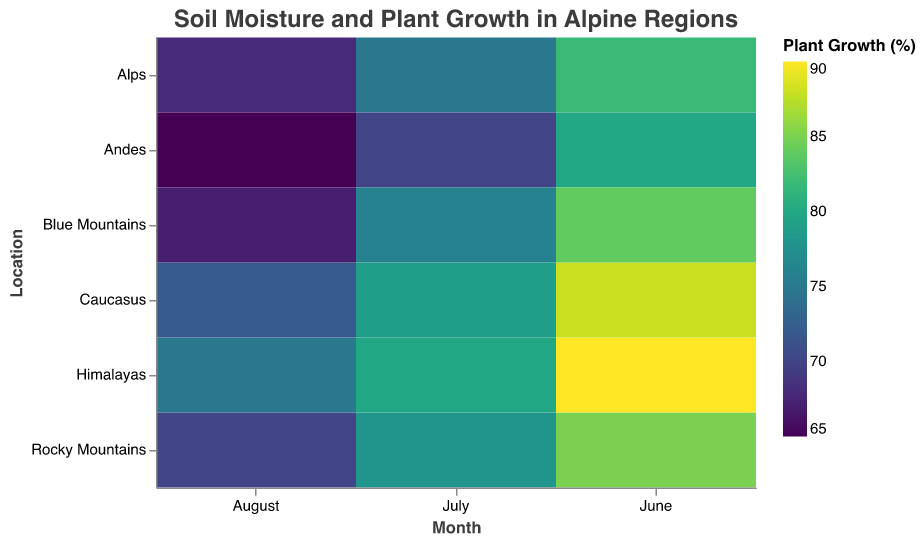What is the soil moisture percentage in the Himalayas in August? Locate the Himalayas row and the August column in the heatmap. The tooltip or cell value should indicate the soil moisture percentage.
Answer: 32% Which location has the highest plant growth percentage in June? Identify the June column and find the cell with the highest plant growth percentage. Use the tooltip or cell value to determine the specific location.
Answer: Himalayas What is the average soil moisture percentage across all locations in July? Find the values for soil moisture in July for all locations: Rocky Mountains (35), Himalayas (40), Alps (36), Andes (33), Caucasus (37), Blue Mountains (34). Calculate the average: (35+40+36+33+37+34)/6.
Answer: 35.83 Which location shows the greatest decrease in plant growth percentage from June to August? Compare the plant growth percentages from June to August for each location. Calculate the differences and identify the location with the largest drop. For example, Rocky Mountains: 85 - 70 = 15. Repeat for each location and find the maximum decline.
Answer: Alps How does the plant growth percentage change in the Blue Mountains from June to July? Look at the plant growth percentages in the Blue Mountains for June (84) and July (76). Subtract the July value from the June value to find the change.
Answer: Decrease by 8% Which month generally has the lowest soil moisture percentage across all locations? Compare the soil moisture percentages for June, July, and August across all locations. Sum the values for each month and find the month with the lowest total.
Answer: August Is there a correlation between soil moisture and plant growth percentage in the Alps over the three months? Check the values of soil moisture and plant growth for the Alps in June, July, and August. Calculate the correlation. For example, June (45, 82), July (36, 75), August (28, 68). Observe the pattern (as soil moisture decreases, plant growth also decreases).
Answer: Yes, positive correlation Which location has the least variation in soil moisture percentage across the three months? Calculate the variation (difference between the highest and lowest values) for soil moisture in each location. E.g., Rocky Mountains: 42 - 30 = 12. Do the same for all locations and find the smallest variation.
Answer: Andes What is the total plant growth percentage in the Caucasus over June, July, and August? Sum the plant growth percentages for the Caucasus in June (88), July (79), and August (72): 88 + 79 + 72.
Answer: 239% 